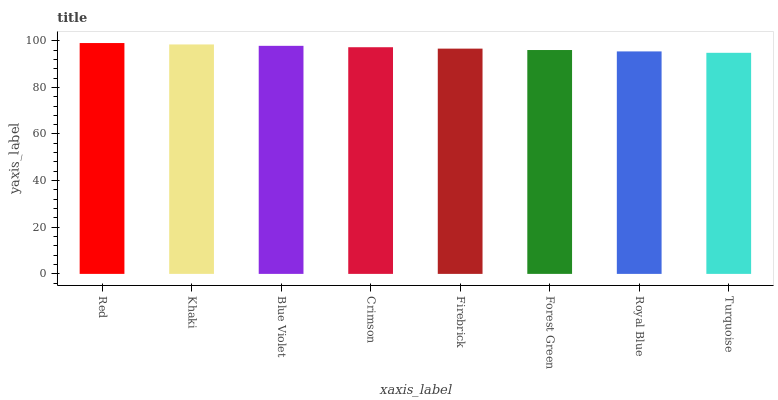Is Turquoise the minimum?
Answer yes or no. Yes. Is Red the maximum?
Answer yes or no. Yes. Is Khaki the minimum?
Answer yes or no. No. Is Khaki the maximum?
Answer yes or no. No. Is Red greater than Khaki?
Answer yes or no. Yes. Is Khaki less than Red?
Answer yes or no. Yes. Is Khaki greater than Red?
Answer yes or no. No. Is Red less than Khaki?
Answer yes or no. No. Is Crimson the high median?
Answer yes or no. Yes. Is Firebrick the low median?
Answer yes or no. Yes. Is Blue Violet the high median?
Answer yes or no. No. Is Khaki the low median?
Answer yes or no. No. 